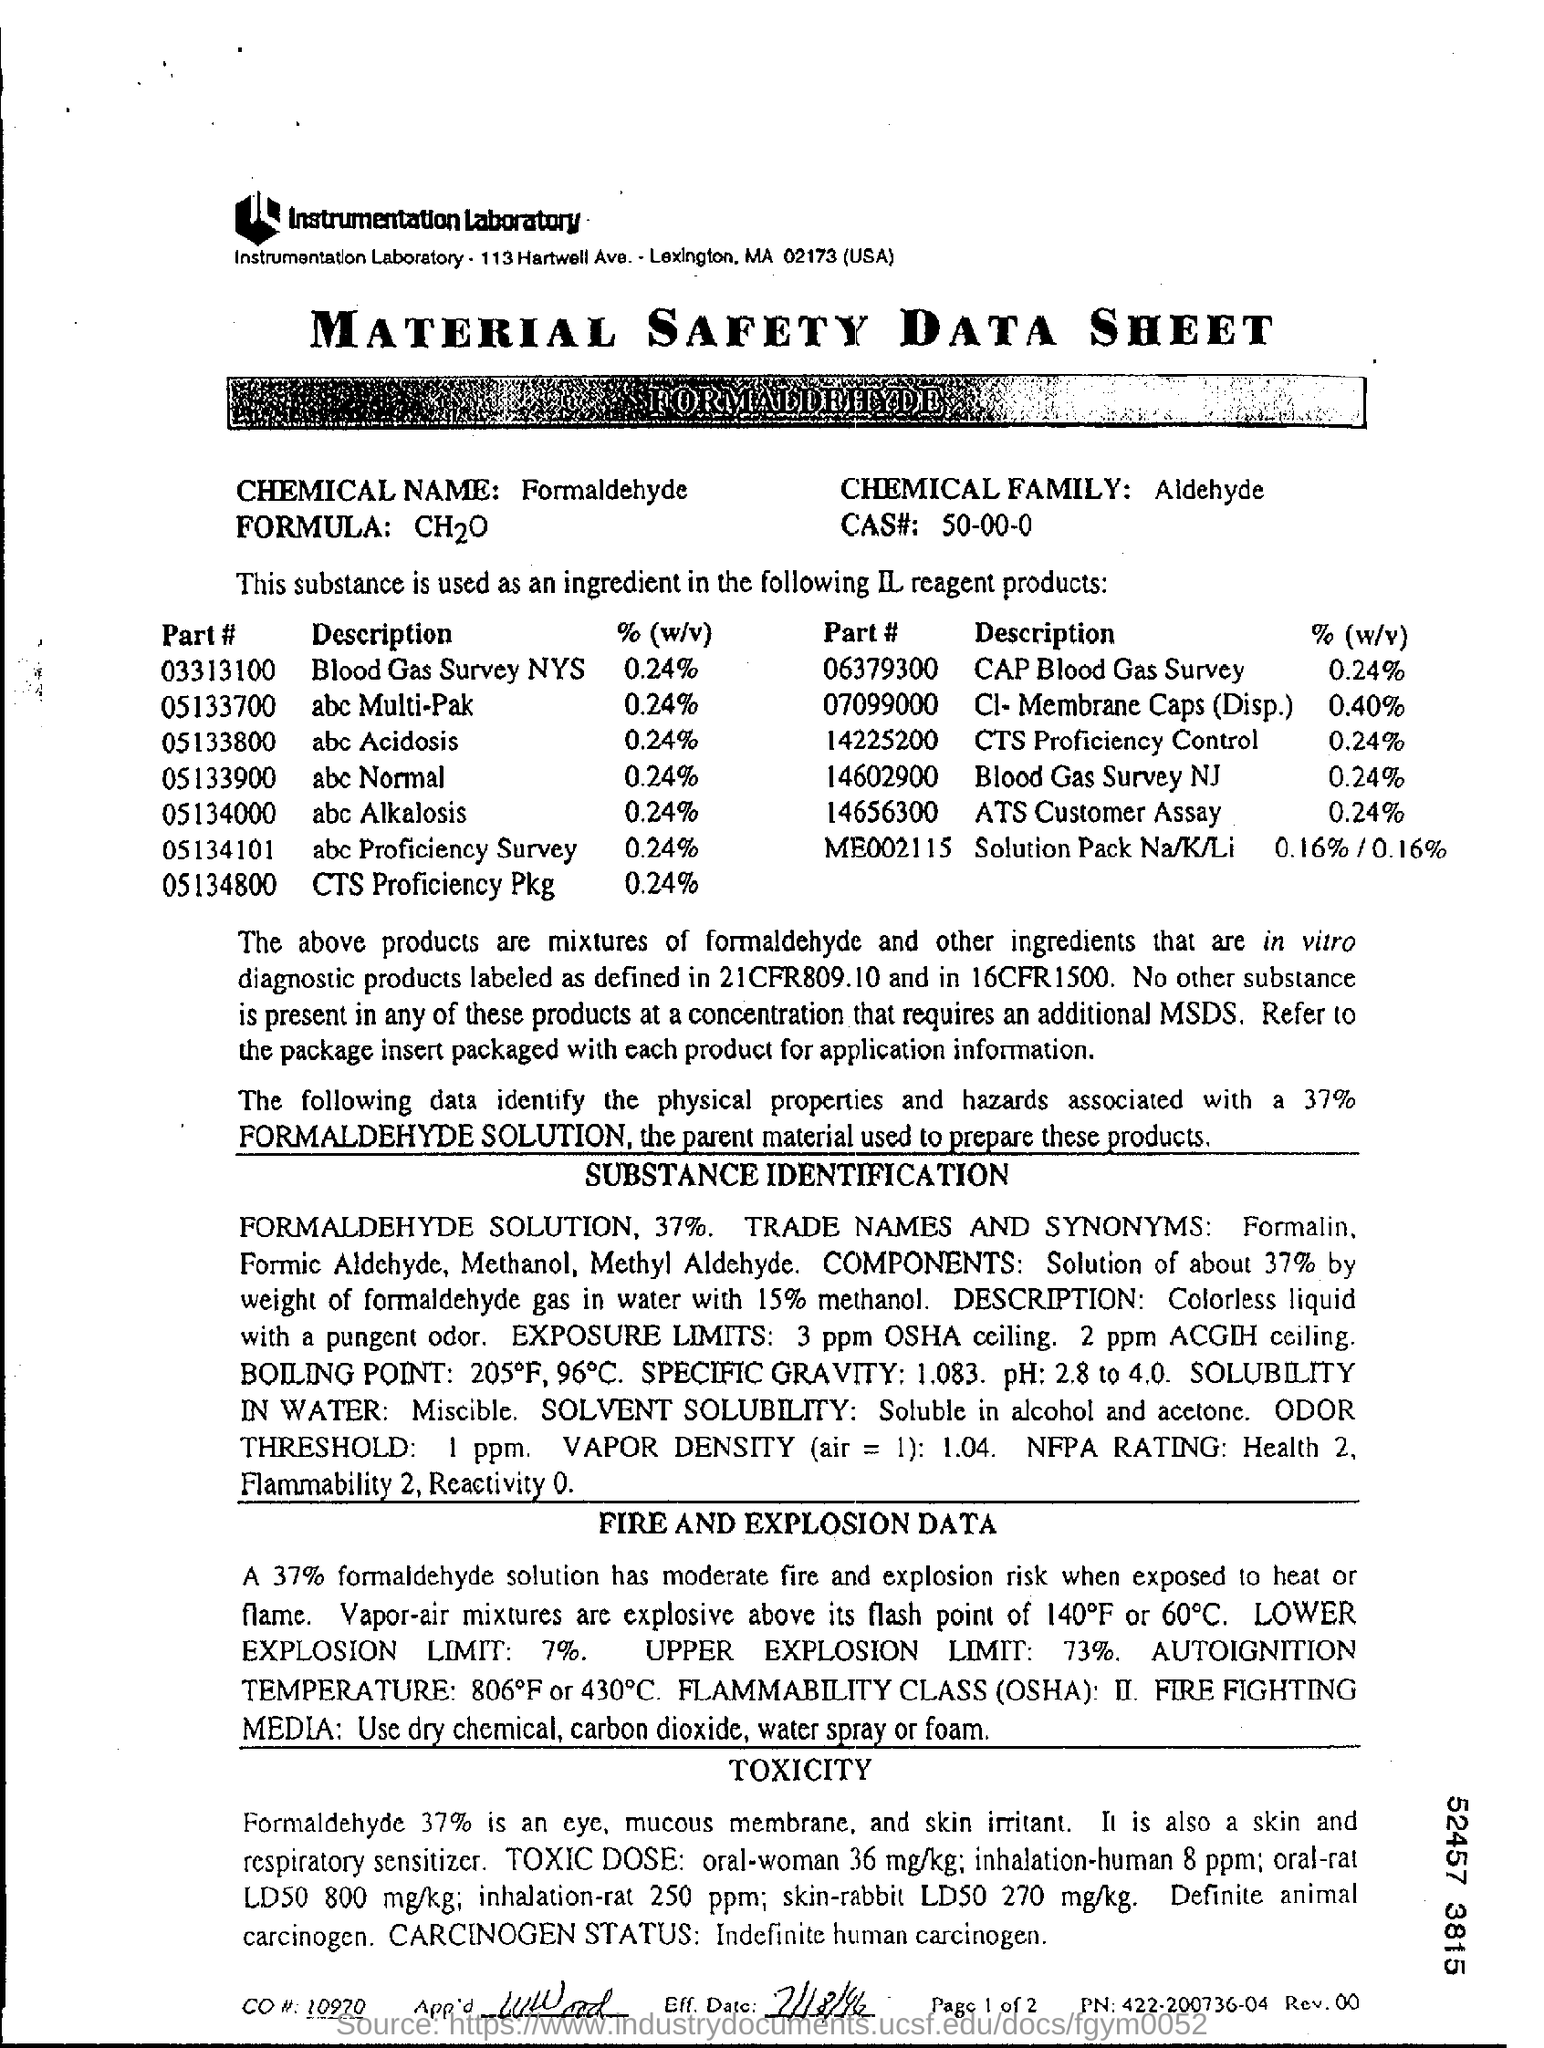Point out several critical features in this image. The upper explosion limit is 73%. The %(w/v) of the abc Alkalosis is 0.24%. The CAS number for a chemical compound is a unique identifier assigned by the Chemical Abstracts Service, a division of the American Chemical Society. The CAS number consists of eight digits, with the first five digits representing a prefix that indicates the class of chemicals and the last three digits representing the specific chemical identity. The CAS number is used to identify and track chemicals in scientific research, commerce, and regulatory contexts. Part # 05133700 is described as an 'abc Multi-Pak'. 